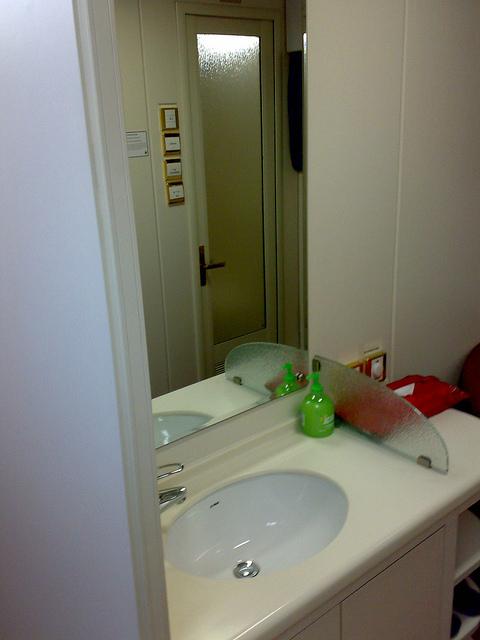What does the sign on the wall mean?
Concise answer only. No sign. Is this a double sink?
Write a very short answer. No. Is the bathroom clean?
Concise answer only. Yes. Is the sink empty?
Write a very short answer. Yes. 